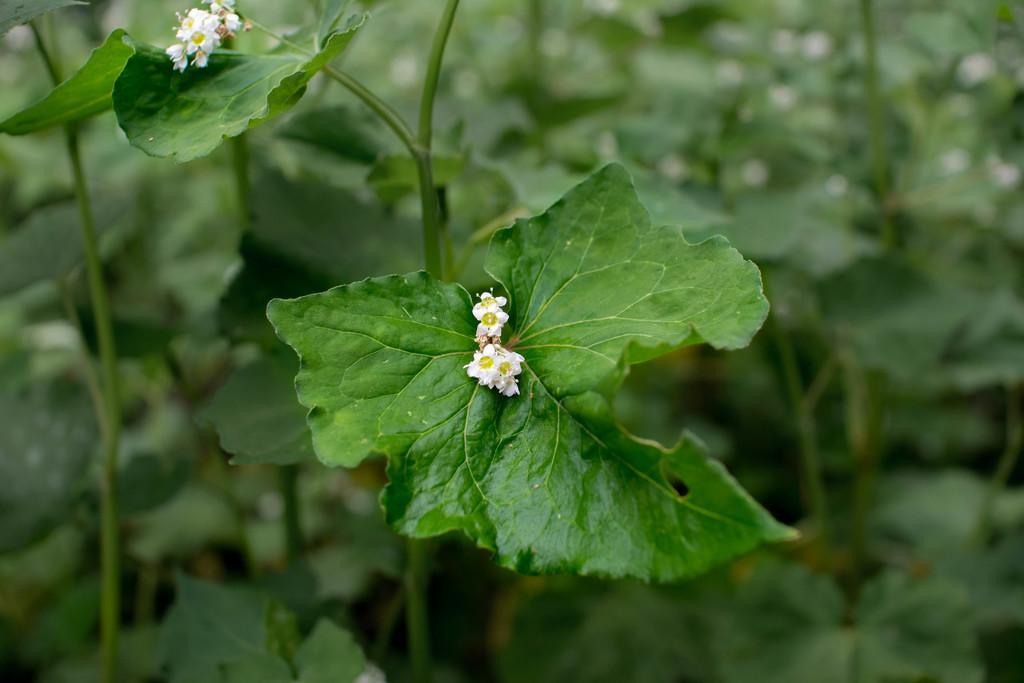Can you describe this image briefly? In this image, we can see plants and there are some flowers, which are in white color. 